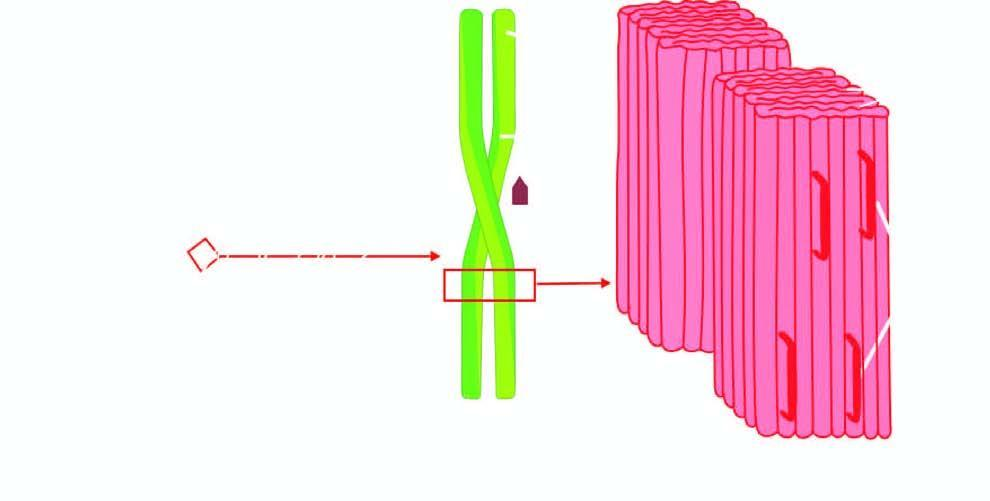does these end components of chromosome have a pentagonal or doughnut profile?
Answer the question using a single word or phrase. No 